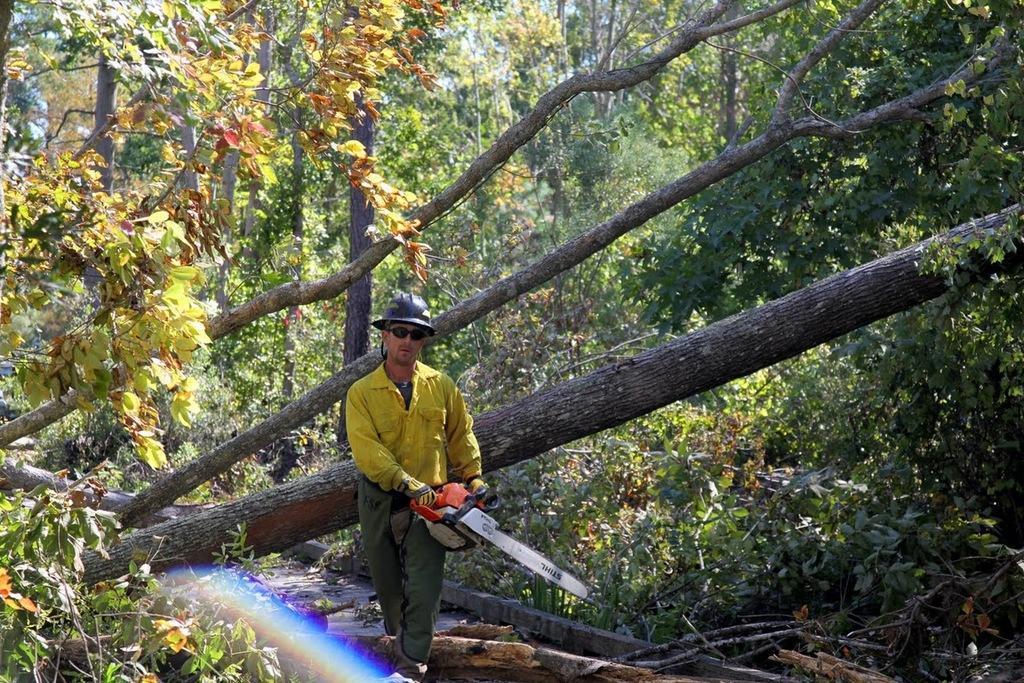Please provide a concise description of this image. In the middle of this image, there is a person in a yellow color shirt, wearing a helmet and sunglasses and holding a chainsaw. Beside him, there are trees which are fallen. On the left side, there are trees on the ground. On the right side, there are plants and trees on the ground. In the background, there are trees. 